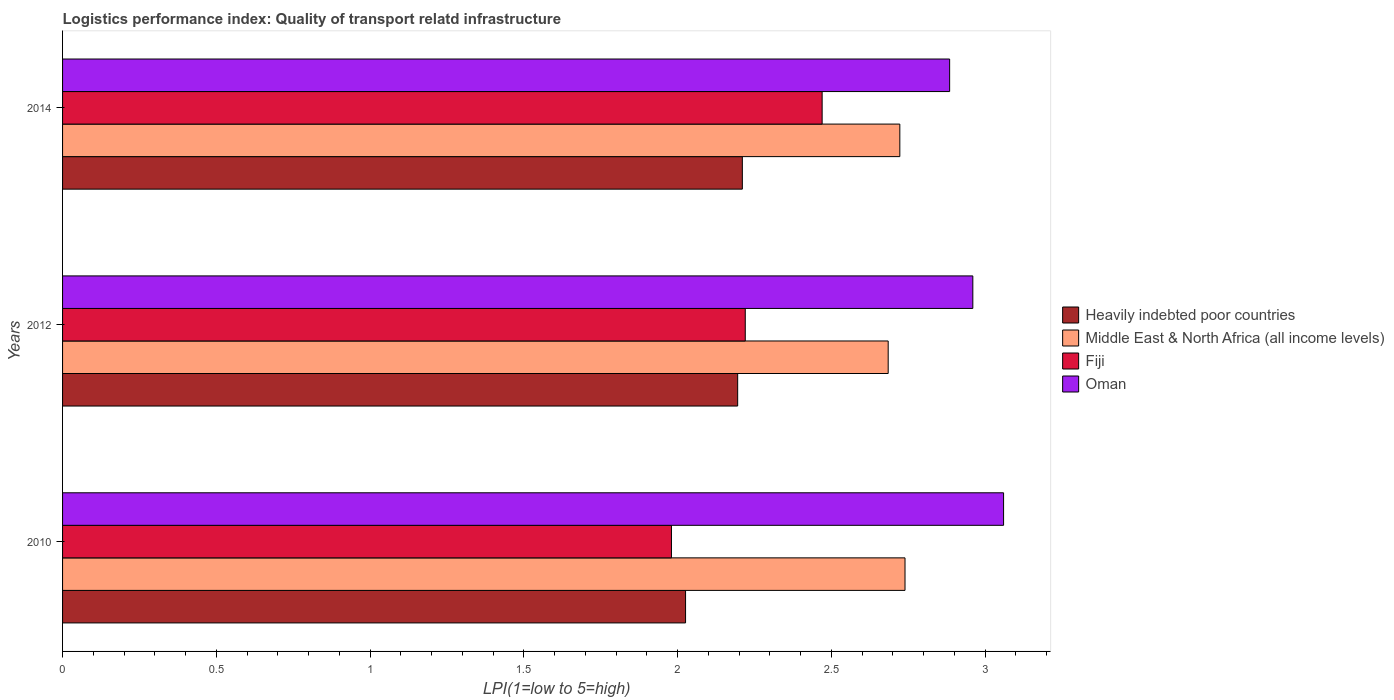Are the number of bars per tick equal to the number of legend labels?
Provide a succinct answer. Yes. What is the label of the 3rd group of bars from the top?
Offer a terse response. 2010. What is the logistics performance index in Fiji in 2010?
Offer a very short reply. 1.98. Across all years, what is the maximum logistics performance index in Heavily indebted poor countries?
Keep it short and to the point. 2.21. Across all years, what is the minimum logistics performance index in Fiji?
Provide a succinct answer. 1.98. In which year was the logistics performance index in Heavily indebted poor countries maximum?
Keep it short and to the point. 2014. In which year was the logistics performance index in Heavily indebted poor countries minimum?
Your answer should be very brief. 2010. What is the total logistics performance index in Fiji in the graph?
Your response must be concise. 6.67. What is the difference between the logistics performance index in Oman in 2010 and that in 2012?
Provide a succinct answer. 0.1. What is the difference between the logistics performance index in Fiji in 2010 and the logistics performance index in Oman in 2012?
Offer a very short reply. -0.98. What is the average logistics performance index in Oman per year?
Offer a very short reply. 2.97. In the year 2010, what is the difference between the logistics performance index in Oman and logistics performance index in Middle East & North Africa (all income levels)?
Give a very brief answer. 0.32. In how many years, is the logistics performance index in Fiji greater than 1.8 ?
Your response must be concise. 3. What is the ratio of the logistics performance index in Oman in 2010 to that in 2012?
Ensure brevity in your answer.  1.03. Is the difference between the logistics performance index in Oman in 2010 and 2014 greater than the difference between the logistics performance index in Middle East & North Africa (all income levels) in 2010 and 2014?
Ensure brevity in your answer.  Yes. What is the difference between the highest and the second highest logistics performance index in Oman?
Your answer should be very brief. 0.1. What is the difference between the highest and the lowest logistics performance index in Oman?
Your answer should be very brief. 0.18. Is the sum of the logistics performance index in Middle East & North Africa (all income levels) in 2010 and 2014 greater than the maximum logistics performance index in Oman across all years?
Your answer should be compact. Yes. What does the 2nd bar from the top in 2010 represents?
Your answer should be compact. Fiji. What does the 4th bar from the bottom in 2014 represents?
Give a very brief answer. Oman. Is it the case that in every year, the sum of the logistics performance index in Middle East & North Africa (all income levels) and logistics performance index in Oman is greater than the logistics performance index in Fiji?
Your answer should be compact. Yes. Does the graph contain any zero values?
Keep it short and to the point. No. Does the graph contain grids?
Ensure brevity in your answer.  No. Where does the legend appear in the graph?
Your response must be concise. Center right. How many legend labels are there?
Offer a terse response. 4. How are the legend labels stacked?
Ensure brevity in your answer.  Vertical. What is the title of the graph?
Offer a very short reply. Logistics performance index: Quality of transport relatd infrastructure. Does "Korea (Democratic)" appear as one of the legend labels in the graph?
Provide a short and direct response. No. What is the label or title of the X-axis?
Keep it short and to the point. LPI(1=low to 5=high). What is the label or title of the Y-axis?
Make the answer very short. Years. What is the LPI(1=low to 5=high) in Heavily indebted poor countries in 2010?
Provide a succinct answer. 2.03. What is the LPI(1=low to 5=high) in Middle East & North Africa (all income levels) in 2010?
Offer a terse response. 2.74. What is the LPI(1=low to 5=high) of Fiji in 2010?
Your answer should be compact. 1.98. What is the LPI(1=low to 5=high) in Oman in 2010?
Give a very brief answer. 3.06. What is the LPI(1=low to 5=high) of Heavily indebted poor countries in 2012?
Make the answer very short. 2.2. What is the LPI(1=low to 5=high) in Middle East & North Africa (all income levels) in 2012?
Keep it short and to the point. 2.68. What is the LPI(1=low to 5=high) in Fiji in 2012?
Your response must be concise. 2.22. What is the LPI(1=low to 5=high) of Oman in 2012?
Give a very brief answer. 2.96. What is the LPI(1=low to 5=high) in Heavily indebted poor countries in 2014?
Ensure brevity in your answer.  2.21. What is the LPI(1=low to 5=high) in Middle East & North Africa (all income levels) in 2014?
Ensure brevity in your answer.  2.72. What is the LPI(1=low to 5=high) in Fiji in 2014?
Your answer should be very brief. 2.47. What is the LPI(1=low to 5=high) of Oman in 2014?
Offer a terse response. 2.88. Across all years, what is the maximum LPI(1=low to 5=high) in Heavily indebted poor countries?
Your answer should be compact. 2.21. Across all years, what is the maximum LPI(1=low to 5=high) of Middle East & North Africa (all income levels)?
Provide a short and direct response. 2.74. Across all years, what is the maximum LPI(1=low to 5=high) of Fiji?
Provide a short and direct response. 2.47. Across all years, what is the maximum LPI(1=low to 5=high) in Oman?
Your response must be concise. 3.06. Across all years, what is the minimum LPI(1=low to 5=high) in Heavily indebted poor countries?
Keep it short and to the point. 2.03. Across all years, what is the minimum LPI(1=low to 5=high) in Middle East & North Africa (all income levels)?
Make the answer very short. 2.68. Across all years, what is the minimum LPI(1=low to 5=high) of Fiji?
Offer a terse response. 1.98. Across all years, what is the minimum LPI(1=low to 5=high) of Oman?
Your answer should be very brief. 2.88. What is the total LPI(1=low to 5=high) of Heavily indebted poor countries in the graph?
Provide a succinct answer. 6.43. What is the total LPI(1=low to 5=high) in Middle East & North Africa (all income levels) in the graph?
Offer a terse response. 8.15. What is the total LPI(1=low to 5=high) of Fiji in the graph?
Ensure brevity in your answer.  6.67. What is the total LPI(1=low to 5=high) of Oman in the graph?
Your answer should be very brief. 8.9. What is the difference between the LPI(1=low to 5=high) of Heavily indebted poor countries in 2010 and that in 2012?
Make the answer very short. -0.17. What is the difference between the LPI(1=low to 5=high) in Middle East & North Africa (all income levels) in 2010 and that in 2012?
Offer a terse response. 0.05. What is the difference between the LPI(1=low to 5=high) of Fiji in 2010 and that in 2012?
Your answer should be very brief. -0.24. What is the difference between the LPI(1=low to 5=high) of Oman in 2010 and that in 2012?
Provide a succinct answer. 0.1. What is the difference between the LPI(1=low to 5=high) in Heavily indebted poor countries in 2010 and that in 2014?
Offer a terse response. -0.18. What is the difference between the LPI(1=low to 5=high) of Middle East & North Africa (all income levels) in 2010 and that in 2014?
Give a very brief answer. 0.02. What is the difference between the LPI(1=low to 5=high) of Fiji in 2010 and that in 2014?
Provide a short and direct response. -0.49. What is the difference between the LPI(1=low to 5=high) in Oman in 2010 and that in 2014?
Give a very brief answer. 0.18. What is the difference between the LPI(1=low to 5=high) of Heavily indebted poor countries in 2012 and that in 2014?
Offer a very short reply. -0.02. What is the difference between the LPI(1=low to 5=high) in Middle East & North Africa (all income levels) in 2012 and that in 2014?
Your answer should be very brief. -0.04. What is the difference between the LPI(1=low to 5=high) of Oman in 2012 and that in 2014?
Provide a short and direct response. 0.08. What is the difference between the LPI(1=low to 5=high) of Heavily indebted poor countries in 2010 and the LPI(1=low to 5=high) of Middle East & North Africa (all income levels) in 2012?
Your answer should be very brief. -0.66. What is the difference between the LPI(1=low to 5=high) in Heavily indebted poor countries in 2010 and the LPI(1=low to 5=high) in Fiji in 2012?
Provide a succinct answer. -0.19. What is the difference between the LPI(1=low to 5=high) of Heavily indebted poor countries in 2010 and the LPI(1=low to 5=high) of Oman in 2012?
Your answer should be compact. -0.93. What is the difference between the LPI(1=low to 5=high) in Middle East & North Africa (all income levels) in 2010 and the LPI(1=low to 5=high) in Fiji in 2012?
Provide a short and direct response. 0.52. What is the difference between the LPI(1=low to 5=high) of Middle East & North Africa (all income levels) in 2010 and the LPI(1=low to 5=high) of Oman in 2012?
Provide a succinct answer. -0.22. What is the difference between the LPI(1=low to 5=high) of Fiji in 2010 and the LPI(1=low to 5=high) of Oman in 2012?
Give a very brief answer. -0.98. What is the difference between the LPI(1=low to 5=high) in Heavily indebted poor countries in 2010 and the LPI(1=low to 5=high) in Middle East & North Africa (all income levels) in 2014?
Give a very brief answer. -0.7. What is the difference between the LPI(1=low to 5=high) in Heavily indebted poor countries in 2010 and the LPI(1=low to 5=high) in Fiji in 2014?
Provide a succinct answer. -0.44. What is the difference between the LPI(1=low to 5=high) of Heavily indebted poor countries in 2010 and the LPI(1=low to 5=high) of Oman in 2014?
Your answer should be compact. -0.86. What is the difference between the LPI(1=low to 5=high) in Middle East & North Africa (all income levels) in 2010 and the LPI(1=low to 5=high) in Fiji in 2014?
Your response must be concise. 0.27. What is the difference between the LPI(1=low to 5=high) in Middle East & North Africa (all income levels) in 2010 and the LPI(1=low to 5=high) in Oman in 2014?
Make the answer very short. -0.15. What is the difference between the LPI(1=low to 5=high) in Fiji in 2010 and the LPI(1=low to 5=high) in Oman in 2014?
Make the answer very short. -0.9. What is the difference between the LPI(1=low to 5=high) in Heavily indebted poor countries in 2012 and the LPI(1=low to 5=high) in Middle East & North Africa (all income levels) in 2014?
Provide a succinct answer. -0.53. What is the difference between the LPI(1=low to 5=high) of Heavily indebted poor countries in 2012 and the LPI(1=low to 5=high) of Fiji in 2014?
Your response must be concise. -0.27. What is the difference between the LPI(1=low to 5=high) of Heavily indebted poor countries in 2012 and the LPI(1=low to 5=high) of Oman in 2014?
Keep it short and to the point. -0.69. What is the difference between the LPI(1=low to 5=high) of Middle East & North Africa (all income levels) in 2012 and the LPI(1=low to 5=high) of Fiji in 2014?
Provide a short and direct response. 0.21. What is the difference between the LPI(1=low to 5=high) in Middle East & North Africa (all income levels) in 2012 and the LPI(1=low to 5=high) in Oman in 2014?
Offer a very short reply. -0.2. What is the difference between the LPI(1=low to 5=high) of Fiji in 2012 and the LPI(1=low to 5=high) of Oman in 2014?
Offer a very short reply. -0.66. What is the average LPI(1=low to 5=high) in Heavily indebted poor countries per year?
Your answer should be compact. 2.14. What is the average LPI(1=low to 5=high) in Middle East & North Africa (all income levels) per year?
Make the answer very short. 2.72. What is the average LPI(1=low to 5=high) in Fiji per year?
Give a very brief answer. 2.22. What is the average LPI(1=low to 5=high) of Oman per year?
Offer a terse response. 2.97. In the year 2010, what is the difference between the LPI(1=low to 5=high) in Heavily indebted poor countries and LPI(1=low to 5=high) in Middle East & North Africa (all income levels)?
Provide a succinct answer. -0.71. In the year 2010, what is the difference between the LPI(1=low to 5=high) in Heavily indebted poor countries and LPI(1=low to 5=high) in Fiji?
Offer a terse response. 0.05. In the year 2010, what is the difference between the LPI(1=low to 5=high) in Heavily indebted poor countries and LPI(1=low to 5=high) in Oman?
Give a very brief answer. -1.03. In the year 2010, what is the difference between the LPI(1=low to 5=high) in Middle East & North Africa (all income levels) and LPI(1=low to 5=high) in Fiji?
Make the answer very short. 0.76. In the year 2010, what is the difference between the LPI(1=low to 5=high) in Middle East & North Africa (all income levels) and LPI(1=low to 5=high) in Oman?
Keep it short and to the point. -0.32. In the year 2010, what is the difference between the LPI(1=low to 5=high) in Fiji and LPI(1=low to 5=high) in Oman?
Offer a terse response. -1.08. In the year 2012, what is the difference between the LPI(1=low to 5=high) in Heavily indebted poor countries and LPI(1=low to 5=high) in Middle East & North Africa (all income levels)?
Keep it short and to the point. -0.49. In the year 2012, what is the difference between the LPI(1=low to 5=high) in Heavily indebted poor countries and LPI(1=low to 5=high) in Fiji?
Make the answer very short. -0.02. In the year 2012, what is the difference between the LPI(1=low to 5=high) in Heavily indebted poor countries and LPI(1=low to 5=high) in Oman?
Keep it short and to the point. -0.76. In the year 2012, what is the difference between the LPI(1=low to 5=high) in Middle East & North Africa (all income levels) and LPI(1=low to 5=high) in Fiji?
Offer a very short reply. 0.46. In the year 2012, what is the difference between the LPI(1=low to 5=high) in Middle East & North Africa (all income levels) and LPI(1=low to 5=high) in Oman?
Ensure brevity in your answer.  -0.28. In the year 2012, what is the difference between the LPI(1=low to 5=high) in Fiji and LPI(1=low to 5=high) in Oman?
Your answer should be compact. -0.74. In the year 2014, what is the difference between the LPI(1=low to 5=high) of Heavily indebted poor countries and LPI(1=low to 5=high) of Middle East & North Africa (all income levels)?
Keep it short and to the point. -0.51. In the year 2014, what is the difference between the LPI(1=low to 5=high) of Heavily indebted poor countries and LPI(1=low to 5=high) of Fiji?
Provide a short and direct response. -0.26. In the year 2014, what is the difference between the LPI(1=low to 5=high) of Heavily indebted poor countries and LPI(1=low to 5=high) of Oman?
Offer a terse response. -0.67. In the year 2014, what is the difference between the LPI(1=low to 5=high) in Middle East & North Africa (all income levels) and LPI(1=low to 5=high) in Fiji?
Offer a very short reply. 0.25. In the year 2014, what is the difference between the LPI(1=low to 5=high) in Middle East & North Africa (all income levels) and LPI(1=low to 5=high) in Oman?
Offer a terse response. -0.16. In the year 2014, what is the difference between the LPI(1=low to 5=high) in Fiji and LPI(1=low to 5=high) in Oman?
Your response must be concise. -0.41. What is the ratio of the LPI(1=low to 5=high) of Heavily indebted poor countries in 2010 to that in 2012?
Your answer should be very brief. 0.92. What is the ratio of the LPI(1=low to 5=high) of Middle East & North Africa (all income levels) in 2010 to that in 2012?
Your answer should be very brief. 1.02. What is the ratio of the LPI(1=low to 5=high) in Fiji in 2010 to that in 2012?
Your answer should be compact. 0.89. What is the ratio of the LPI(1=low to 5=high) of Oman in 2010 to that in 2012?
Provide a short and direct response. 1.03. What is the ratio of the LPI(1=low to 5=high) in Heavily indebted poor countries in 2010 to that in 2014?
Offer a terse response. 0.92. What is the ratio of the LPI(1=low to 5=high) in Middle East & North Africa (all income levels) in 2010 to that in 2014?
Provide a short and direct response. 1.01. What is the ratio of the LPI(1=low to 5=high) of Fiji in 2010 to that in 2014?
Offer a very short reply. 0.8. What is the ratio of the LPI(1=low to 5=high) in Oman in 2010 to that in 2014?
Offer a terse response. 1.06. What is the ratio of the LPI(1=low to 5=high) in Middle East & North Africa (all income levels) in 2012 to that in 2014?
Make the answer very short. 0.99. What is the ratio of the LPI(1=low to 5=high) in Fiji in 2012 to that in 2014?
Provide a short and direct response. 0.9. What is the ratio of the LPI(1=low to 5=high) of Oman in 2012 to that in 2014?
Ensure brevity in your answer.  1.03. What is the difference between the highest and the second highest LPI(1=low to 5=high) of Heavily indebted poor countries?
Your response must be concise. 0.02. What is the difference between the highest and the second highest LPI(1=low to 5=high) of Middle East & North Africa (all income levels)?
Ensure brevity in your answer.  0.02. What is the difference between the highest and the second highest LPI(1=low to 5=high) in Fiji?
Provide a succinct answer. 0.25. What is the difference between the highest and the second highest LPI(1=low to 5=high) in Oman?
Provide a succinct answer. 0.1. What is the difference between the highest and the lowest LPI(1=low to 5=high) of Heavily indebted poor countries?
Your answer should be very brief. 0.18. What is the difference between the highest and the lowest LPI(1=low to 5=high) in Middle East & North Africa (all income levels)?
Give a very brief answer. 0.05. What is the difference between the highest and the lowest LPI(1=low to 5=high) of Fiji?
Offer a terse response. 0.49. What is the difference between the highest and the lowest LPI(1=low to 5=high) in Oman?
Provide a short and direct response. 0.18. 